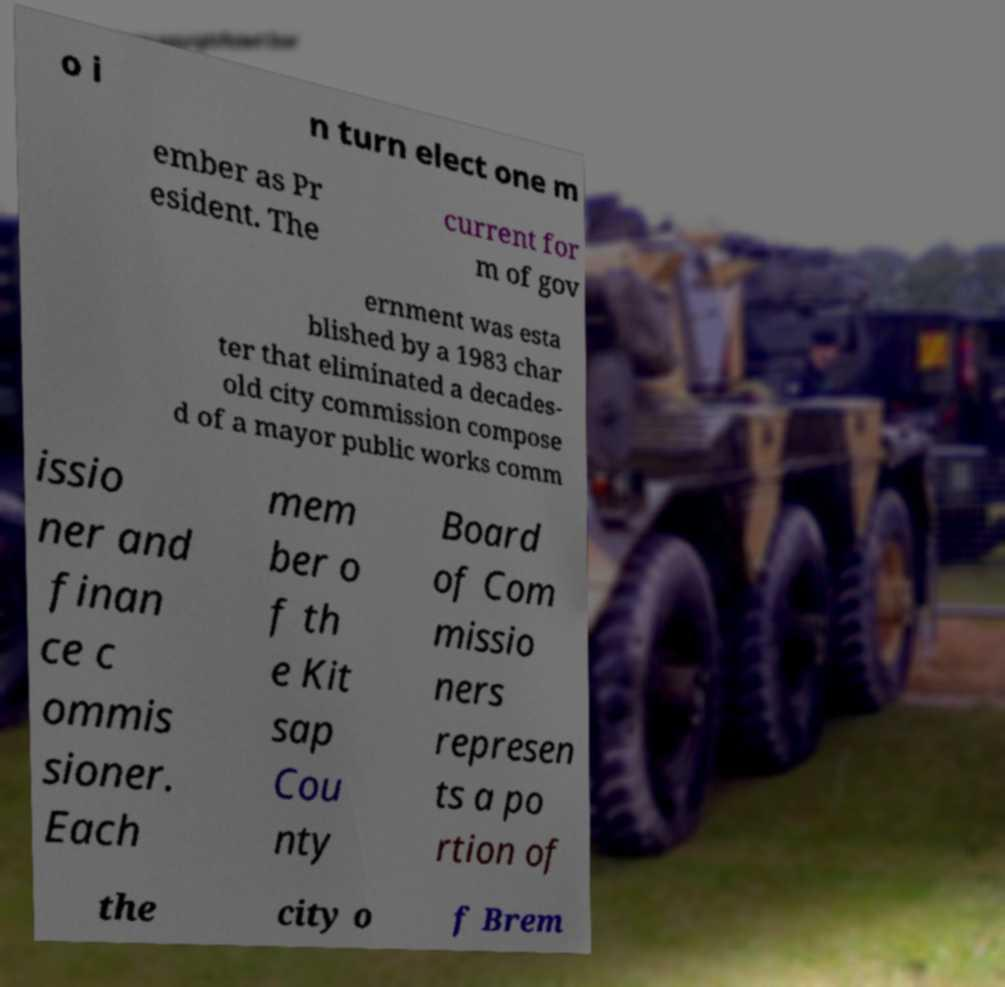There's text embedded in this image that I need extracted. Can you transcribe it verbatim? o i n turn elect one m ember as Pr esident. The current for m of gov ernment was esta blished by a 1983 char ter that eliminated a decades- old city commission compose d of a mayor public works comm issio ner and finan ce c ommis sioner. Each mem ber o f th e Kit sap Cou nty Board of Com missio ners represen ts a po rtion of the city o f Brem 